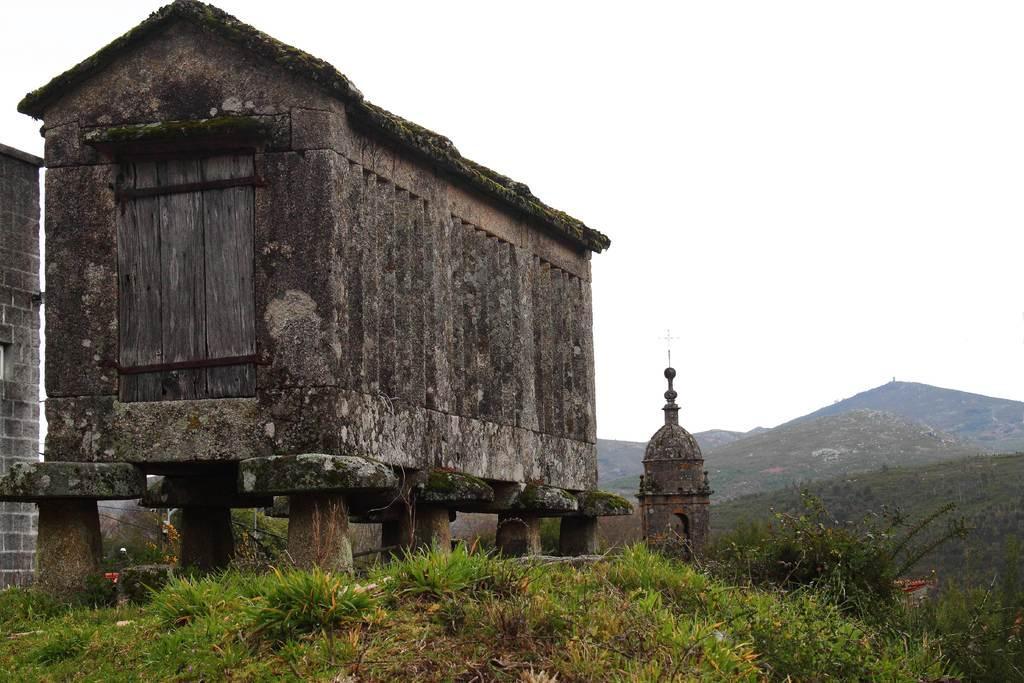Could you give a brief overview of what you see in this image? In this image in the front there are plants on the ground and in the center there is a tower and there are mountains in the background. On the left side there is a barrack and there is a wall. 